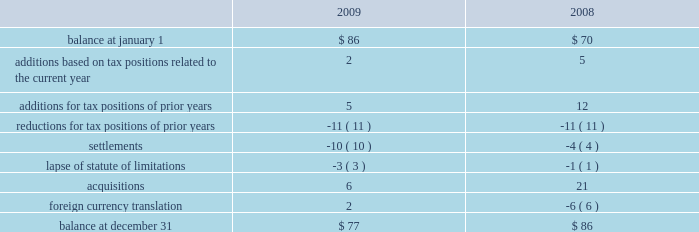At december 31 , 2009 , aon had domestic federal operating loss carryforwards of $ 7 million that will expire at various dates from 2010 to 2024 , state operating loss carryforwards of $ 513 million that will expire at various dates from 2010 to 2028 , and foreign operating and capital loss carryforwards of $ 453 million and $ 252 million , respectively , nearly all of which are subject to indefinite carryforward .
Unrecognized tax benefits the following is a reconciliation of the company 2019s beginning and ending amount of unrecognized tax benefits ( in millions ) : .
As of december 31 , 2009 , $ 61 million of unrecognized tax benefits would impact the effective tax rate if recognized .
Aon does not expect the unrecognized tax positions to change significantly over the next twelve months .
The company recognizes penalties and interest related to unrecognized income tax benefits in its provision for income taxes .
Aon accrued potential penalties of less than $ 1 million during each of 2009 , 2008 and 2007 .
Aon accrued interest of $ 2 million during 2009 and less than $ 1 million during both 2008 and 2007 .
As of december 31 , 2009 and 2008 , aon has recorded a liability for penalties of $ 5 million and $ 4 million , respectively , and for interest of $ 18 million and $ 14 million , respectively .
Aon and its subsidiaries file income tax returns in the u.s .
Federal jurisdiction as well as various state and international jurisdictions .
Aon has substantially concluded all u.s .
Federal income tax matters for years through 2006 .
Material u.s .
State and local income tax jurisdiction examinations have been concluded for years through 2002 .
Aon has concluded income tax examinations in its primary international jurisdictions through 2002. .
What was the percent of the change in the unrecognized tax benefits from 2008 to 2009? 
Computations: ((77 - 86) / 86)
Answer: -0.10465. 